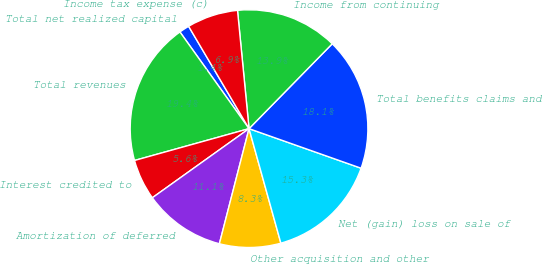Convert chart to OTSL. <chart><loc_0><loc_0><loc_500><loc_500><pie_chart><fcel>Total net realized capital<fcel>Total revenues<fcel>Interest credited to<fcel>Amortization of deferred<fcel>Other acquisition and other<fcel>Net (gain) loss on sale of<fcel>Total benefits claims and<fcel>Income from continuing<fcel>Income tax expense (c)<nl><fcel>1.39%<fcel>19.44%<fcel>5.56%<fcel>11.11%<fcel>8.33%<fcel>15.28%<fcel>18.06%<fcel>13.89%<fcel>6.94%<nl></chart> 